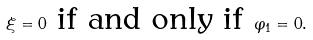Convert formula to latex. <formula><loc_0><loc_0><loc_500><loc_500>\xi = 0 \text { if and only if } \varphi _ { 1 } = 0 .</formula> 